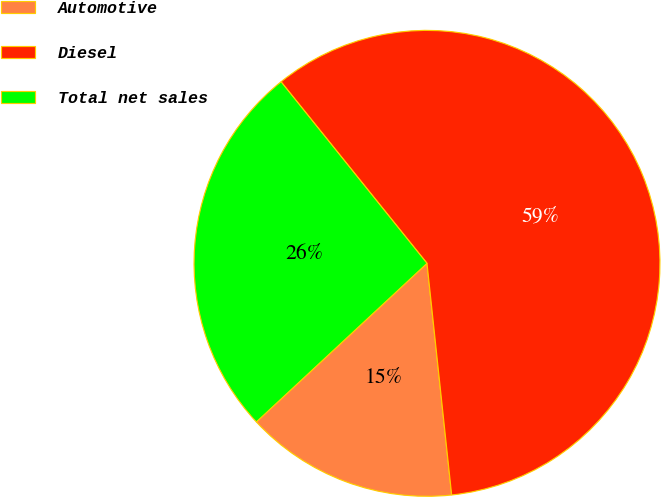Convert chart. <chart><loc_0><loc_0><loc_500><loc_500><pie_chart><fcel>Automotive<fcel>Diesel<fcel>Total net sales<nl><fcel>14.77%<fcel>59.09%<fcel>26.14%<nl></chart> 